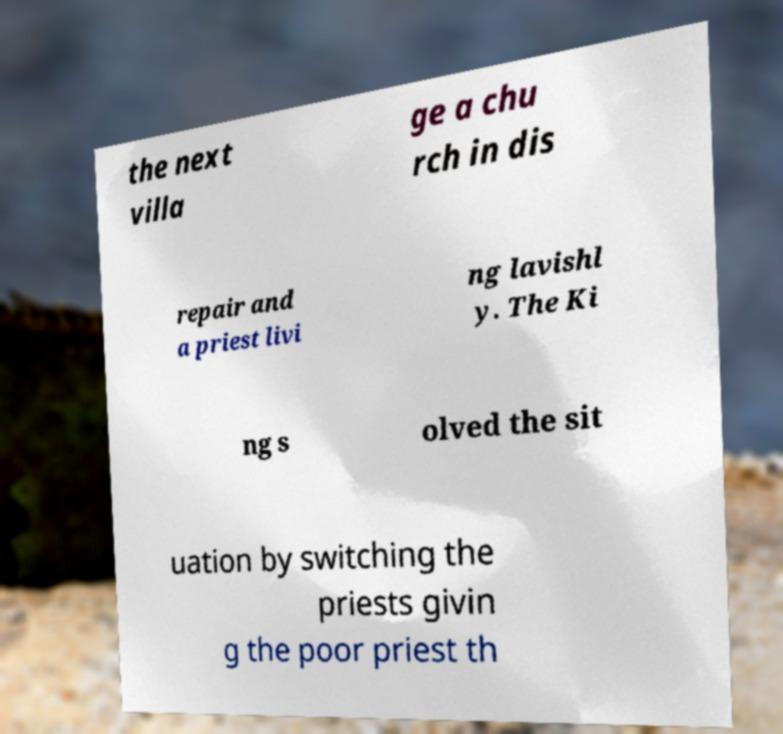Can you accurately transcribe the text from the provided image for me? the next villa ge a chu rch in dis repair and a priest livi ng lavishl y. The Ki ng s olved the sit uation by switching the priests givin g the poor priest th 